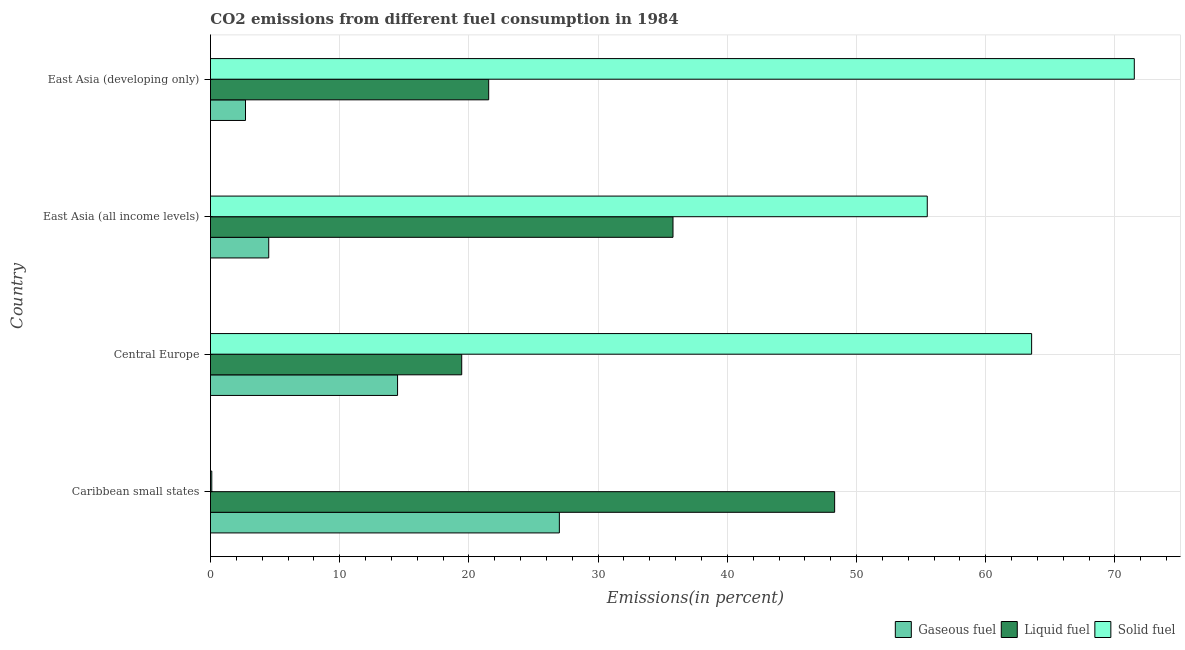How many different coloured bars are there?
Offer a terse response. 3. Are the number of bars per tick equal to the number of legend labels?
Ensure brevity in your answer.  Yes. Are the number of bars on each tick of the Y-axis equal?
Provide a succinct answer. Yes. How many bars are there on the 1st tick from the bottom?
Your answer should be very brief. 3. What is the label of the 4th group of bars from the top?
Ensure brevity in your answer.  Caribbean small states. In how many cases, is the number of bars for a given country not equal to the number of legend labels?
Give a very brief answer. 0. What is the percentage of solid fuel emission in East Asia (all income levels)?
Your answer should be compact. 55.47. Across all countries, what is the maximum percentage of solid fuel emission?
Keep it short and to the point. 71.5. Across all countries, what is the minimum percentage of gaseous fuel emission?
Offer a very short reply. 2.71. In which country was the percentage of gaseous fuel emission maximum?
Offer a terse response. Caribbean small states. In which country was the percentage of liquid fuel emission minimum?
Ensure brevity in your answer.  Central Europe. What is the total percentage of liquid fuel emission in the graph?
Your answer should be compact. 125.08. What is the difference between the percentage of gaseous fuel emission in Central Europe and that in East Asia (developing only)?
Offer a terse response. 11.77. What is the difference between the percentage of gaseous fuel emission in Central Europe and the percentage of liquid fuel emission in East Asia (all income levels)?
Ensure brevity in your answer.  -21.32. What is the average percentage of solid fuel emission per country?
Your response must be concise. 47.66. What is the difference between the percentage of gaseous fuel emission and percentage of liquid fuel emission in Central Europe?
Your response must be concise. -4.96. What is the ratio of the percentage of liquid fuel emission in Central Europe to that in East Asia (developing only)?
Provide a succinct answer. 0.9. Is the percentage of gaseous fuel emission in Caribbean small states less than that in East Asia (all income levels)?
Ensure brevity in your answer.  No. What is the difference between the highest and the second highest percentage of gaseous fuel emission?
Offer a terse response. 12.52. What is the difference between the highest and the lowest percentage of gaseous fuel emission?
Ensure brevity in your answer.  24.29. What does the 1st bar from the top in East Asia (all income levels) represents?
Make the answer very short. Solid fuel. What does the 3rd bar from the bottom in Caribbean small states represents?
Ensure brevity in your answer.  Solid fuel. Are all the bars in the graph horizontal?
Give a very brief answer. Yes. What is the difference between two consecutive major ticks on the X-axis?
Provide a succinct answer. 10. How are the legend labels stacked?
Keep it short and to the point. Horizontal. What is the title of the graph?
Keep it short and to the point. CO2 emissions from different fuel consumption in 1984. Does "Refusal of sex" appear as one of the legend labels in the graph?
Provide a short and direct response. No. What is the label or title of the X-axis?
Give a very brief answer. Emissions(in percent). What is the label or title of the Y-axis?
Your answer should be compact. Country. What is the Emissions(in percent) of Gaseous fuel in Caribbean small states?
Provide a succinct answer. 27. What is the Emissions(in percent) of Liquid fuel in Caribbean small states?
Your answer should be compact. 48.31. What is the Emissions(in percent) of Solid fuel in Caribbean small states?
Ensure brevity in your answer.  0.1. What is the Emissions(in percent) in Gaseous fuel in Central Europe?
Your answer should be compact. 14.48. What is the Emissions(in percent) in Liquid fuel in Central Europe?
Offer a very short reply. 19.44. What is the Emissions(in percent) in Solid fuel in Central Europe?
Your answer should be very brief. 63.55. What is the Emissions(in percent) of Gaseous fuel in East Asia (all income levels)?
Ensure brevity in your answer.  4.51. What is the Emissions(in percent) of Liquid fuel in East Asia (all income levels)?
Make the answer very short. 35.8. What is the Emissions(in percent) of Solid fuel in East Asia (all income levels)?
Keep it short and to the point. 55.47. What is the Emissions(in percent) in Gaseous fuel in East Asia (developing only)?
Ensure brevity in your answer.  2.71. What is the Emissions(in percent) in Liquid fuel in East Asia (developing only)?
Your response must be concise. 21.53. What is the Emissions(in percent) of Solid fuel in East Asia (developing only)?
Your response must be concise. 71.5. Across all countries, what is the maximum Emissions(in percent) of Gaseous fuel?
Provide a short and direct response. 27. Across all countries, what is the maximum Emissions(in percent) of Liquid fuel?
Ensure brevity in your answer.  48.31. Across all countries, what is the maximum Emissions(in percent) in Solid fuel?
Provide a succinct answer. 71.5. Across all countries, what is the minimum Emissions(in percent) in Gaseous fuel?
Your answer should be very brief. 2.71. Across all countries, what is the minimum Emissions(in percent) in Liquid fuel?
Provide a succinct answer. 19.44. Across all countries, what is the minimum Emissions(in percent) in Solid fuel?
Keep it short and to the point. 0.1. What is the total Emissions(in percent) in Gaseous fuel in the graph?
Make the answer very short. 48.7. What is the total Emissions(in percent) in Liquid fuel in the graph?
Keep it short and to the point. 125.08. What is the total Emissions(in percent) in Solid fuel in the graph?
Keep it short and to the point. 190.62. What is the difference between the Emissions(in percent) of Gaseous fuel in Caribbean small states and that in Central Europe?
Make the answer very short. 12.52. What is the difference between the Emissions(in percent) of Liquid fuel in Caribbean small states and that in Central Europe?
Ensure brevity in your answer.  28.86. What is the difference between the Emissions(in percent) of Solid fuel in Caribbean small states and that in Central Europe?
Your answer should be compact. -63.45. What is the difference between the Emissions(in percent) of Gaseous fuel in Caribbean small states and that in East Asia (all income levels)?
Keep it short and to the point. 22.49. What is the difference between the Emissions(in percent) of Liquid fuel in Caribbean small states and that in East Asia (all income levels)?
Your response must be concise. 12.51. What is the difference between the Emissions(in percent) in Solid fuel in Caribbean small states and that in East Asia (all income levels)?
Your response must be concise. -55.37. What is the difference between the Emissions(in percent) of Gaseous fuel in Caribbean small states and that in East Asia (developing only)?
Your answer should be compact. 24.29. What is the difference between the Emissions(in percent) of Liquid fuel in Caribbean small states and that in East Asia (developing only)?
Your answer should be very brief. 26.77. What is the difference between the Emissions(in percent) of Solid fuel in Caribbean small states and that in East Asia (developing only)?
Provide a short and direct response. -71.4. What is the difference between the Emissions(in percent) in Gaseous fuel in Central Europe and that in East Asia (all income levels)?
Offer a terse response. 9.97. What is the difference between the Emissions(in percent) in Liquid fuel in Central Europe and that in East Asia (all income levels)?
Your answer should be very brief. -16.35. What is the difference between the Emissions(in percent) of Solid fuel in Central Europe and that in East Asia (all income levels)?
Make the answer very short. 8.08. What is the difference between the Emissions(in percent) of Gaseous fuel in Central Europe and that in East Asia (developing only)?
Offer a very short reply. 11.77. What is the difference between the Emissions(in percent) of Liquid fuel in Central Europe and that in East Asia (developing only)?
Provide a short and direct response. -2.09. What is the difference between the Emissions(in percent) in Solid fuel in Central Europe and that in East Asia (developing only)?
Keep it short and to the point. -7.95. What is the difference between the Emissions(in percent) in Gaseous fuel in East Asia (all income levels) and that in East Asia (developing only)?
Ensure brevity in your answer.  1.8. What is the difference between the Emissions(in percent) in Liquid fuel in East Asia (all income levels) and that in East Asia (developing only)?
Make the answer very short. 14.26. What is the difference between the Emissions(in percent) in Solid fuel in East Asia (all income levels) and that in East Asia (developing only)?
Your answer should be compact. -16.02. What is the difference between the Emissions(in percent) of Gaseous fuel in Caribbean small states and the Emissions(in percent) of Liquid fuel in Central Europe?
Keep it short and to the point. 7.56. What is the difference between the Emissions(in percent) of Gaseous fuel in Caribbean small states and the Emissions(in percent) of Solid fuel in Central Europe?
Your answer should be compact. -36.55. What is the difference between the Emissions(in percent) of Liquid fuel in Caribbean small states and the Emissions(in percent) of Solid fuel in Central Europe?
Your response must be concise. -15.25. What is the difference between the Emissions(in percent) in Gaseous fuel in Caribbean small states and the Emissions(in percent) in Liquid fuel in East Asia (all income levels)?
Provide a short and direct response. -8.79. What is the difference between the Emissions(in percent) in Gaseous fuel in Caribbean small states and the Emissions(in percent) in Solid fuel in East Asia (all income levels)?
Provide a succinct answer. -28.47. What is the difference between the Emissions(in percent) in Liquid fuel in Caribbean small states and the Emissions(in percent) in Solid fuel in East Asia (all income levels)?
Offer a very short reply. -7.17. What is the difference between the Emissions(in percent) in Gaseous fuel in Caribbean small states and the Emissions(in percent) in Liquid fuel in East Asia (developing only)?
Provide a succinct answer. 5.47. What is the difference between the Emissions(in percent) of Gaseous fuel in Caribbean small states and the Emissions(in percent) of Solid fuel in East Asia (developing only)?
Ensure brevity in your answer.  -44.5. What is the difference between the Emissions(in percent) in Liquid fuel in Caribbean small states and the Emissions(in percent) in Solid fuel in East Asia (developing only)?
Your answer should be compact. -23.19. What is the difference between the Emissions(in percent) of Gaseous fuel in Central Europe and the Emissions(in percent) of Liquid fuel in East Asia (all income levels)?
Provide a short and direct response. -21.32. What is the difference between the Emissions(in percent) in Gaseous fuel in Central Europe and the Emissions(in percent) in Solid fuel in East Asia (all income levels)?
Give a very brief answer. -40.99. What is the difference between the Emissions(in percent) in Liquid fuel in Central Europe and the Emissions(in percent) in Solid fuel in East Asia (all income levels)?
Your response must be concise. -36.03. What is the difference between the Emissions(in percent) in Gaseous fuel in Central Europe and the Emissions(in percent) in Liquid fuel in East Asia (developing only)?
Provide a short and direct response. -7.05. What is the difference between the Emissions(in percent) of Gaseous fuel in Central Europe and the Emissions(in percent) of Solid fuel in East Asia (developing only)?
Your answer should be compact. -57.02. What is the difference between the Emissions(in percent) of Liquid fuel in Central Europe and the Emissions(in percent) of Solid fuel in East Asia (developing only)?
Make the answer very short. -52.05. What is the difference between the Emissions(in percent) in Gaseous fuel in East Asia (all income levels) and the Emissions(in percent) in Liquid fuel in East Asia (developing only)?
Ensure brevity in your answer.  -17.02. What is the difference between the Emissions(in percent) of Gaseous fuel in East Asia (all income levels) and the Emissions(in percent) of Solid fuel in East Asia (developing only)?
Ensure brevity in your answer.  -66.99. What is the difference between the Emissions(in percent) of Liquid fuel in East Asia (all income levels) and the Emissions(in percent) of Solid fuel in East Asia (developing only)?
Give a very brief answer. -35.7. What is the average Emissions(in percent) in Gaseous fuel per country?
Your answer should be very brief. 12.18. What is the average Emissions(in percent) of Liquid fuel per country?
Ensure brevity in your answer.  31.27. What is the average Emissions(in percent) in Solid fuel per country?
Make the answer very short. 47.66. What is the difference between the Emissions(in percent) of Gaseous fuel and Emissions(in percent) of Liquid fuel in Caribbean small states?
Offer a very short reply. -21.3. What is the difference between the Emissions(in percent) in Gaseous fuel and Emissions(in percent) in Solid fuel in Caribbean small states?
Provide a succinct answer. 26.9. What is the difference between the Emissions(in percent) of Liquid fuel and Emissions(in percent) of Solid fuel in Caribbean small states?
Provide a succinct answer. 48.2. What is the difference between the Emissions(in percent) in Gaseous fuel and Emissions(in percent) in Liquid fuel in Central Europe?
Keep it short and to the point. -4.97. What is the difference between the Emissions(in percent) in Gaseous fuel and Emissions(in percent) in Solid fuel in Central Europe?
Make the answer very short. -49.07. What is the difference between the Emissions(in percent) of Liquid fuel and Emissions(in percent) of Solid fuel in Central Europe?
Provide a short and direct response. -44.11. What is the difference between the Emissions(in percent) of Gaseous fuel and Emissions(in percent) of Liquid fuel in East Asia (all income levels)?
Keep it short and to the point. -31.29. What is the difference between the Emissions(in percent) in Gaseous fuel and Emissions(in percent) in Solid fuel in East Asia (all income levels)?
Offer a terse response. -50.96. What is the difference between the Emissions(in percent) in Liquid fuel and Emissions(in percent) in Solid fuel in East Asia (all income levels)?
Your answer should be very brief. -19.68. What is the difference between the Emissions(in percent) in Gaseous fuel and Emissions(in percent) in Liquid fuel in East Asia (developing only)?
Offer a terse response. -18.82. What is the difference between the Emissions(in percent) in Gaseous fuel and Emissions(in percent) in Solid fuel in East Asia (developing only)?
Keep it short and to the point. -68.79. What is the difference between the Emissions(in percent) of Liquid fuel and Emissions(in percent) of Solid fuel in East Asia (developing only)?
Offer a very short reply. -49.97. What is the ratio of the Emissions(in percent) of Gaseous fuel in Caribbean small states to that in Central Europe?
Make the answer very short. 1.86. What is the ratio of the Emissions(in percent) of Liquid fuel in Caribbean small states to that in Central Europe?
Offer a very short reply. 2.48. What is the ratio of the Emissions(in percent) in Solid fuel in Caribbean small states to that in Central Europe?
Keep it short and to the point. 0. What is the ratio of the Emissions(in percent) in Gaseous fuel in Caribbean small states to that in East Asia (all income levels)?
Your response must be concise. 5.99. What is the ratio of the Emissions(in percent) of Liquid fuel in Caribbean small states to that in East Asia (all income levels)?
Your answer should be compact. 1.35. What is the ratio of the Emissions(in percent) in Solid fuel in Caribbean small states to that in East Asia (all income levels)?
Offer a terse response. 0. What is the ratio of the Emissions(in percent) of Gaseous fuel in Caribbean small states to that in East Asia (developing only)?
Offer a terse response. 9.96. What is the ratio of the Emissions(in percent) in Liquid fuel in Caribbean small states to that in East Asia (developing only)?
Your response must be concise. 2.24. What is the ratio of the Emissions(in percent) in Solid fuel in Caribbean small states to that in East Asia (developing only)?
Ensure brevity in your answer.  0. What is the ratio of the Emissions(in percent) of Gaseous fuel in Central Europe to that in East Asia (all income levels)?
Your response must be concise. 3.21. What is the ratio of the Emissions(in percent) in Liquid fuel in Central Europe to that in East Asia (all income levels)?
Make the answer very short. 0.54. What is the ratio of the Emissions(in percent) in Solid fuel in Central Europe to that in East Asia (all income levels)?
Provide a succinct answer. 1.15. What is the ratio of the Emissions(in percent) in Gaseous fuel in Central Europe to that in East Asia (developing only)?
Your answer should be compact. 5.34. What is the ratio of the Emissions(in percent) in Liquid fuel in Central Europe to that in East Asia (developing only)?
Provide a succinct answer. 0.9. What is the ratio of the Emissions(in percent) in Solid fuel in Central Europe to that in East Asia (developing only)?
Make the answer very short. 0.89. What is the ratio of the Emissions(in percent) in Gaseous fuel in East Asia (all income levels) to that in East Asia (developing only)?
Your response must be concise. 1.66. What is the ratio of the Emissions(in percent) in Liquid fuel in East Asia (all income levels) to that in East Asia (developing only)?
Your answer should be compact. 1.66. What is the ratio of the Emissions(in percent) of Solid fuel in East Asia (all income levels) to that in East Asia (developing only)?
Offer a terse response. 0.78. What is the difference between the highest and the second highest Emissions(in percent) of Gaseous fuel?
Ensure brevity in your answer.  12.52. What is the difference between the highest and the second highest Emissions(in percent) in Liquid fuel?
Provide a succinct answer. 12.51. What is the difference between the highest and the second highest Emissions(in percent) in Solid fuel?
Your answer should be very brief. 7.95. What is the difference between the highest and the lowest Emissions(in percent) of Gaseous fuel?
Provide a succinct answer. 24.29. What is the difference between the highest and the lowest Emissions(in percent) of Liquid fuel?
Provide a succinct answer. 28.86. What is the difference between the highest and the lowest Emissions(in percent) of Solid fuel?
Offer a terse response. 71.4. 